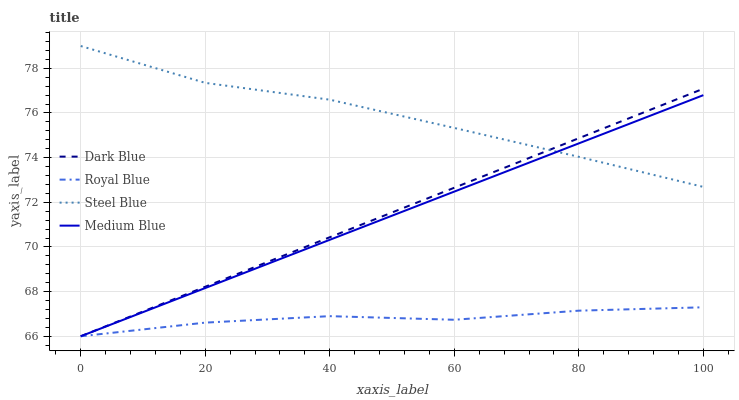Does Medium Blue have the minimum area under the curve?
Answer yes or no. No. Does Medium Blue have the maximum area under the curve?
Answer yes or no. No. Is Steel Blue the smoothest?
Answer yes or no. No. Is Steel Blue the roughest?
Answer yes or no. No. Does Steel Blue have the lowest value?
Answer yes or no. No. Does Medium Blue have the highest value?
Answer yes or no. No. Is Royal Blue less than Steel Blue?
Answer yes or no. Yes. Is Steel Blue greater than Royal Blue?
Answer yes or no. Yes. Does Royal Blue intersect Steel Blue?
Answer yes or no. No. 